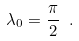<formula> <loc_0><loc_0><loc_500><loc_500>\lambda _ { 0 } = \frac { \pi } { 2 } \ .</formula> 